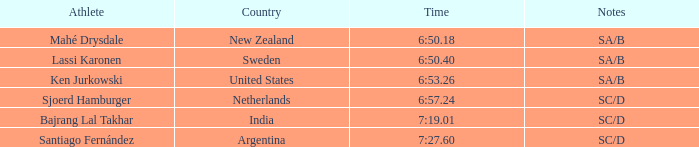Give me the full table as a dictionary. {'header': ['Athlete', 'Country', 'Time', 'Notes'], 'rows': [['Mahé Drysdale', 'New Zealand', '6:50.18', 'SA/B'], ['Lassi Karonen', 'Sweden', '6:50.40', 'SA/B'], ['Ken Jurkowski', 'United States', '6:53.26', 'SA/B'], ['Sjoerd Hamburger', 'Netherlands', '6:57.24', 'SC/D'], ['Bajrang Lal Takhar', 'India', '7:19.01', 'SC/D'], ['Santiago Fernández', 'Argentina', '7:27.60', 'SC/D']]} What is mentioned in the notes regarding the sportsman, lassi karonen? SA/B. 